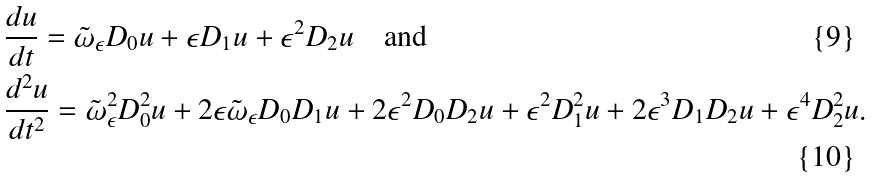Convert formula to latex. <formula><loc_0><loc_0><loc_500><loc_500>& \frac { d u } { d t } = \tilde { \omega } _ { \epsilon } D _ { 0 } u + \epsilon D _ { 1 } u + \epsilon ^ { 2 } D _ { 2 } u \quad \text {and} \\ & \frac { d ^ { 2 } u } { d t ^ { 2 } } = \tilde { \omega } _ { \epsilon } ^ { 2 } D _ { 0 } ^ { 2 } u + 2 \epsilon \tilde { \omega } _ { \epsilon } D _ { 0 } D _ { 1 } u + 2 \epsilon ^ { 2 } D _ { 0 } D _ { 2 } u + \epsilon ^ { 2 } D _ { 1 } ^ { 2 } u + 2 \epsilon ^ { 3 } D _ { 1 } D _ { 2 } u + \epsilon ^ { 4 } D _ { 2 } ^ { 2 } u .</formula> 